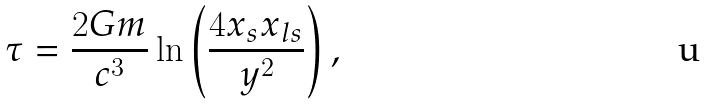<formula> <loc_0><loc_0><loc_500><loc_500>\tau = \frac { 2 G m } { c ^ { 3 } } \ln \left ( \frac { 4 x _ { s } x _ { l s } } { { y } ^ { 2 } } \right ) ,</formula> 